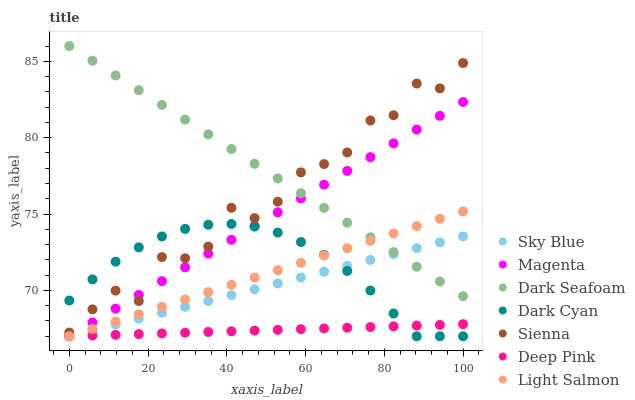Does Deep Pink have the minimum area under the curve?
Answer yes or no. Yes. Does Dark Seafoam have the maximum area under the curve?
Answer yes or no. Yes. Does Sienna have the minimum area under the curve?
Answer yes or no. No. Does Sienna have the maximum area under the curve?
Answer yes or no. No. Is Dark Seafoam the smoothest?
Answer yes or no. Yes. Is Sienna the roughest?
Answer yes or no. Yes. Is Deep Pink the smoothest?
Answer yes or no. No. Is Deep Pink the roughest?
Answer yes or no. No. Does Light Salmon have the lowest value?
Answer yes or no. Yes. Does Sienna have the lowest value?
Answer yes or no. No. Does Dark Seafoam have the highest value?
Answer yes or no. Yes. Does Sienna have the highest value?
Answer yes or no. No. Is Deep Pink less than Sienna?
Answer yes or no. Yes. Is Dark Seafoam greater than Dark Cyan?
Answer yes or no. Yes. Does Sky Blue intersect Light Salmon?
Answer yes or no. Yes. Is Sky Blue less than Light Salmon?
Answer yes or no. No. Is Sky Blue greater than Light Salmon?
Answer yes or no. No. Does Deep Pink intersect Sienna?
Answer yes or no. No. 